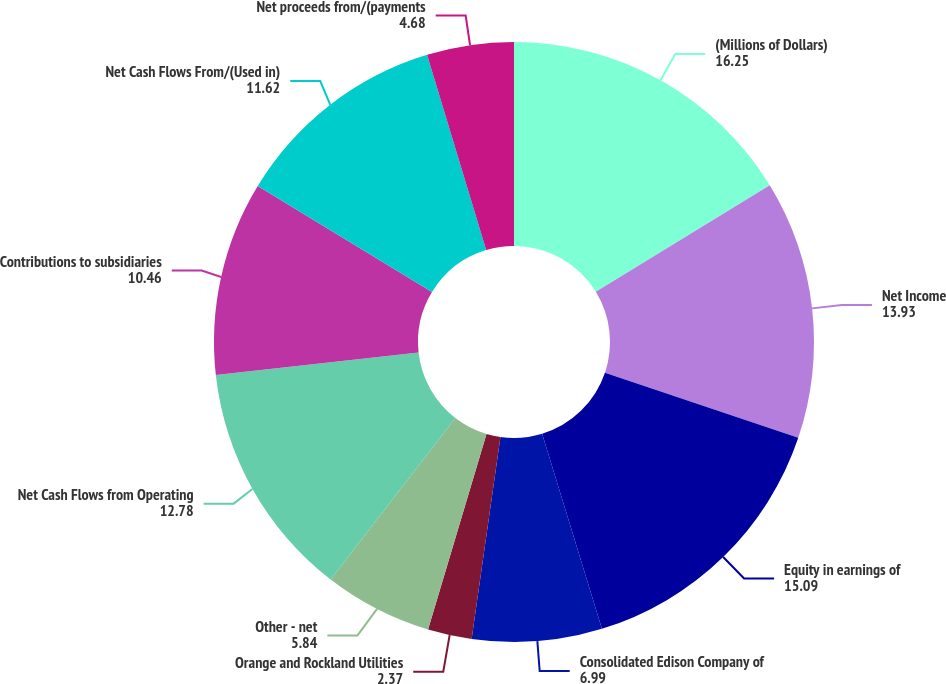<chart> <loc_0><loc_0><loc_500><loc_500><pie_chart><fcel>(Millions of Dollars)<fcel>Net Income<fcel>Equity in earnings of<fcel>Consolidated Edison Company of<fcel>Orange and Rockland Utilities<fcel>Other - net<fcel>Net Cash Flows from Operating<fcel>Contributions to subsidiaries<fcel>Net Cash Flows From/(Used in)<fcel>Net proceeds from/(payments<nl><fcel>16.25%<fcel>13.93%<fcel>15.09%<fcel>6.99%<fcel>2.37%<fcel>5.84%<fcel>12.78%<fcel>10.46%<fcel>11.62%<fcel>4.68%<nl></chart> 